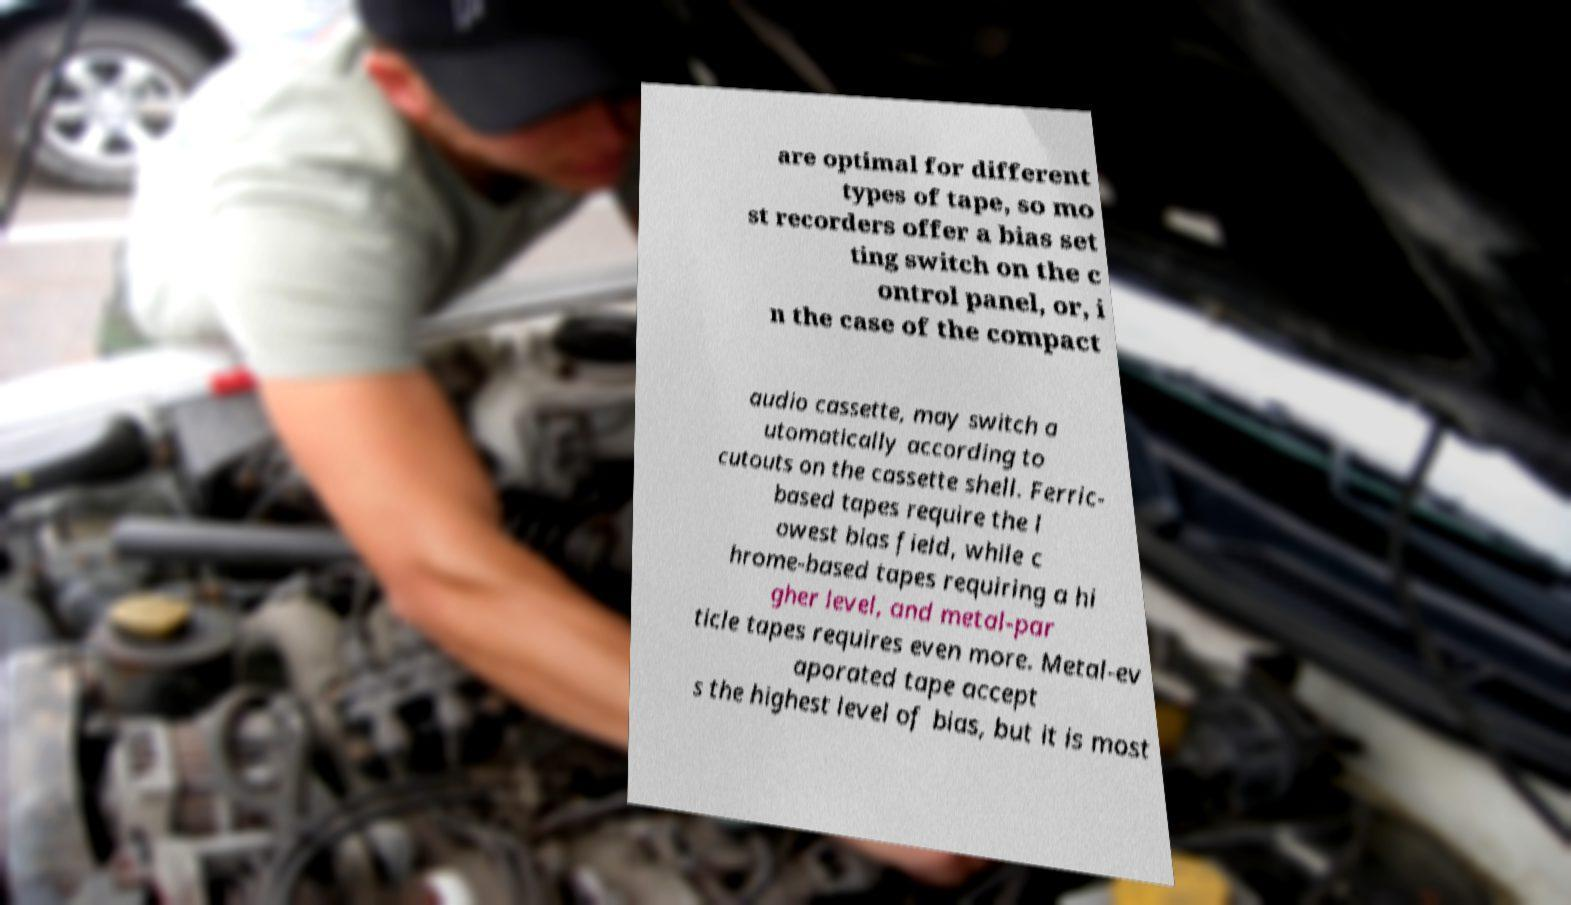Could you extract and type out the text from this image? are optimal for different types of tape, so mo st recorders offer a bias set ting switch on the c ontrol panel, or, i n the case of the compact audio cassette, may switch a utomatically according to cutouts on the cassette shell. Ferric- based tapes require the l owest bias field, while c hrome-based tapes requiring a hi gher level, and metal-par ticle tapes requires even more. Metal-ev aporated tape accept s the highest level of bias, but it is most 